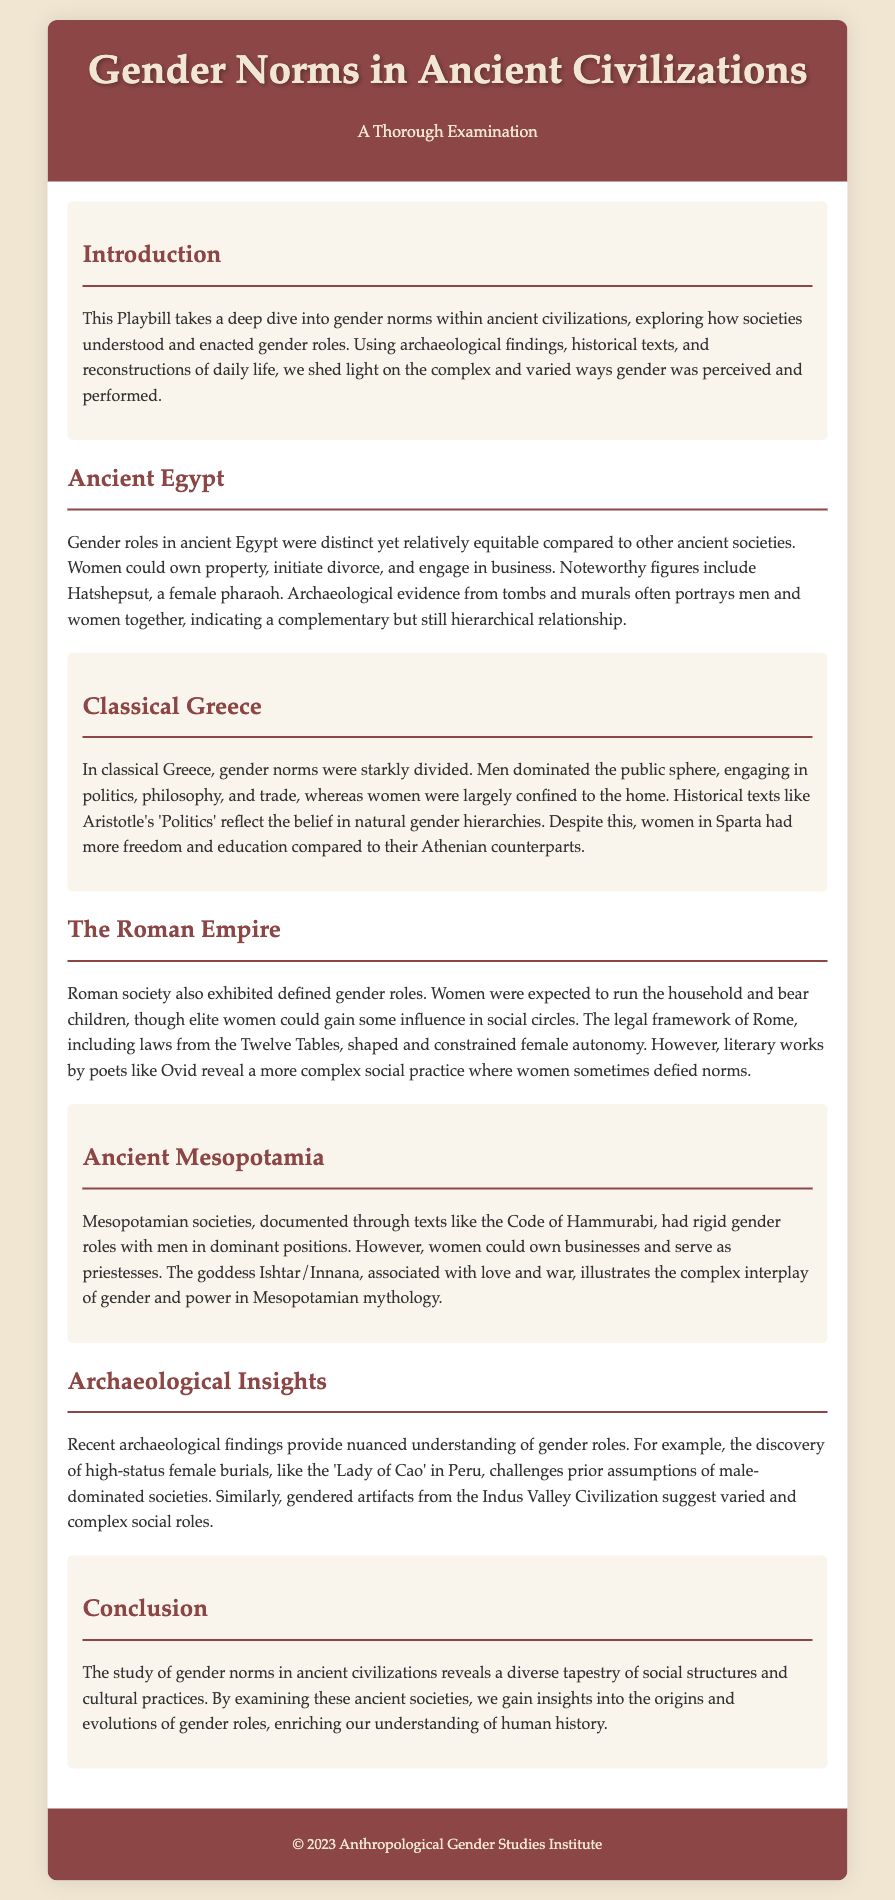What does the playbill examine? The playbill provides a thorough examination of how different ancient civilizations understood and enacted gender roles.
Answer: Gender roles Which civilization had a female pharaoh? The playbill mentions Hatshepsut as a notable figure in ancient Egypt, who was a female pharaoh.
Answer: Ancient Egypt What text reflects the belief in natural gender hierarchies in classical Greece? The playbill states that Aristotle's 'Politics' reflects the belief in natural gender hierarchies.
Answer: Aristotle's 'Politics' Who is associated with love and war in Mesopotamian mythology? The goddess Ishtar/Innana is mentioned as being associated with love and war in Mesopotamian mythology.
Answer: Ishtar/Innana What type of artifacts suggest complex social roles in the Indus Valley Civilization? The playbill indicates that gendered artifacts from the Indus Valley Civilization suggest varied social roles.
Answer: Gendered artifacts What characterizes gender roles in ancient Egypt compared to other civilizations? The playbill notes that gender roles in ancient Egypt were distinct yet relatively equitable.
Answer: Equitable How did women in Sparta differ from their Athenian counterparts? The playbill highlights that women in Sparta had more freedom and education compared to Athenian women.
Answer: More freedom and education What significant findings challenge prior assumptions of male-dominated societies? The playbill references high-status female burials, such as the 'Lady of Cao', as challenging prior assumptions.
Answer: High-status female burials What is the concluding theme of the playbill? The conclusion emphasizes insights into the origins and evolutions of gender roles through examining ancient societies.
Answer: Insights into origins and evolutions of gender roles 